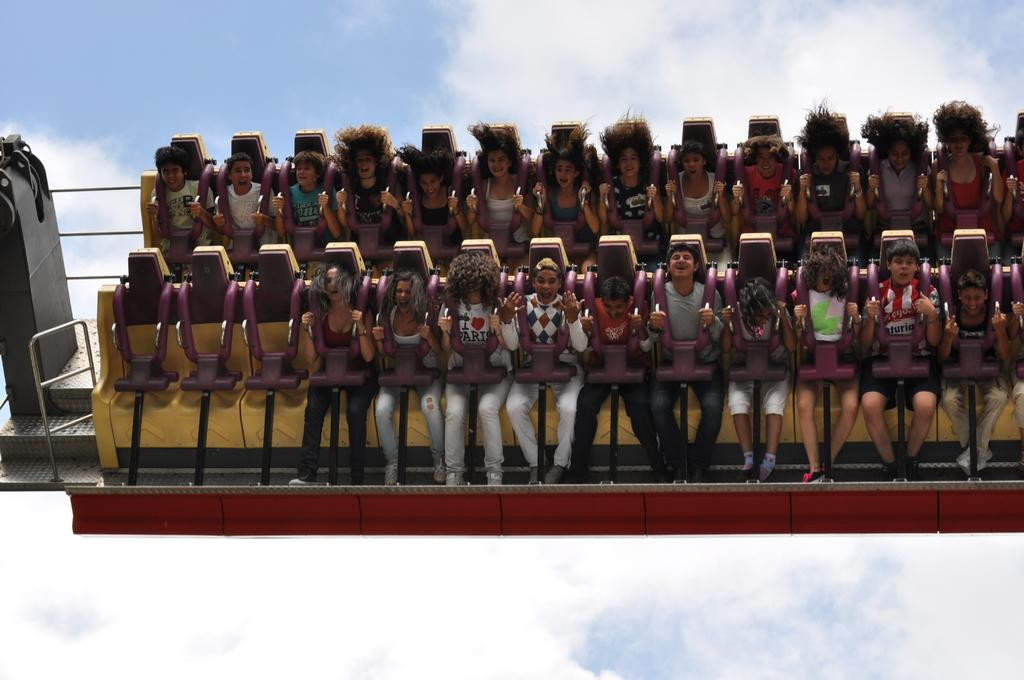What are the people in the image doing? The people in the image are sitting on chairs. What can be seen in the background of the image? The sky is visible in the background of the image. What type of produce is being painted on the canvas in the image? There is no produce or canvas present in the image; it only features people sitting on chairs with the sky visible in the background. 